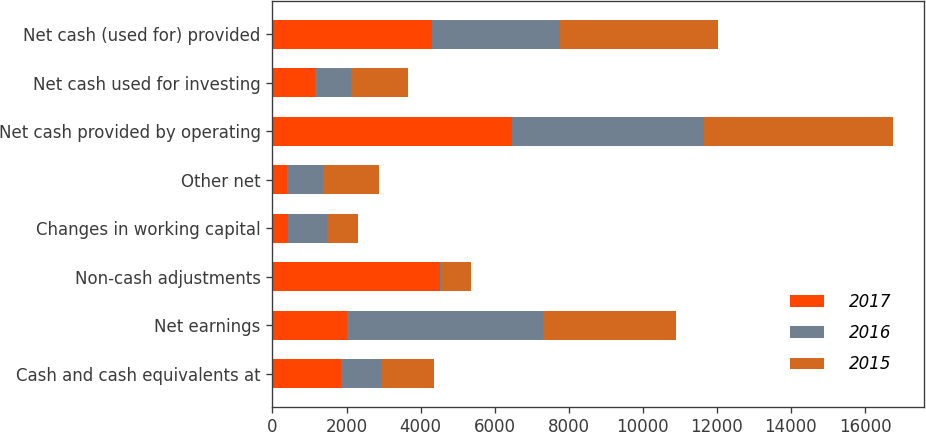Convert chart. <chart><loc_0><loc_0><loc_500><loc_500><stacked_bar_chart><ecel><fcel>Cash and cash equivalents at<fcel>Net earnings<fcel>Non-cash adjustments<fcel>Changes in working capital<fcel>Other net<fcel>Net cash provided by operating<fcel>Net cash used for investing<fcel>Net cash (used for) provided<nl><fcel>2017<fcel>1837<fcel>2002<fcel>4514<fcel>431<fcel>391<fcel>6476<fcel>1147<fcel>4305<nl><fcel>2016<fcel>1090<fcel>5302<fcel>35<fcel>1042<fcel>964<fcel>5189<fcel>985<fcel>3457<nl><fcel>2015<fcel>1446<fcel>3605<fcel>821<fcel>846<fcel>1521<fcel>5101<fcel>1521<fcel>4277<nl></chart> 